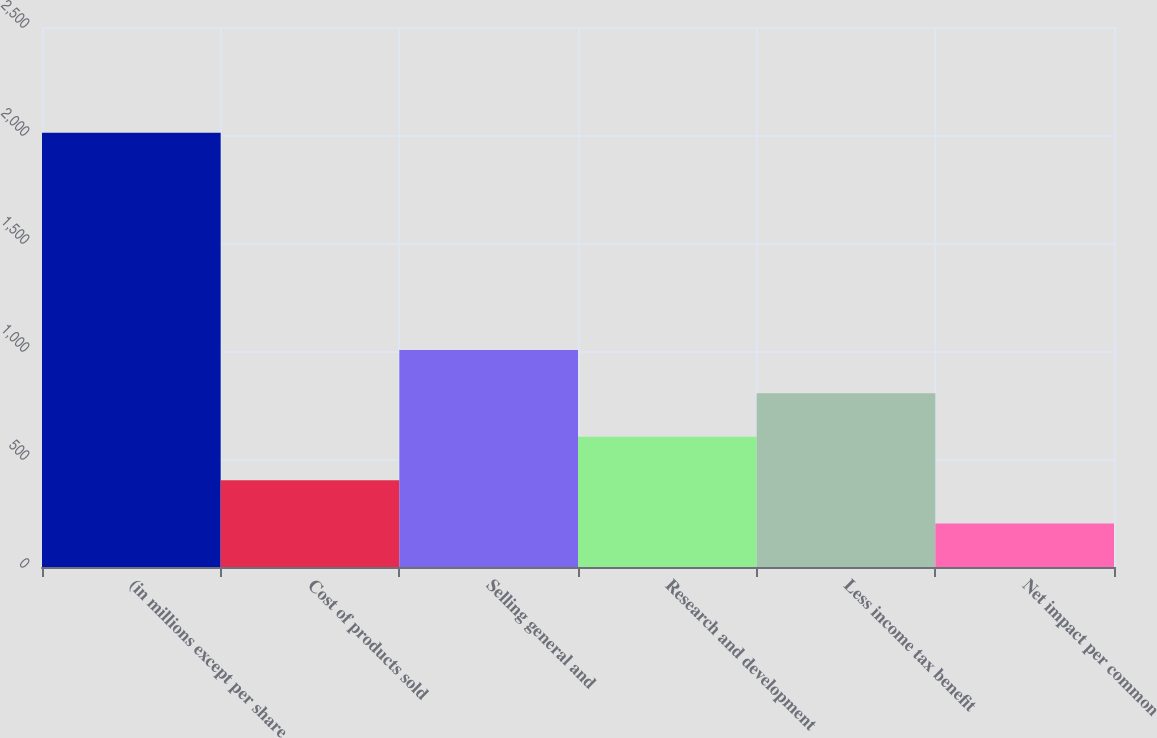Convert chart. <chart><loc_0><loc_0><loc_500><loc_500><bar_chart><fcel>(in millions except per share<fcel>Cost of products sold<fcel>Selling general and<fcel>Research and development<fcel>Less income tax benefit<fcel>Net impact per common<nl><fcel>2010<fcel>402.04<fcel>1005.01<fcel>603.03<fcel>804.02<fcel>201.05<nl></chart> 